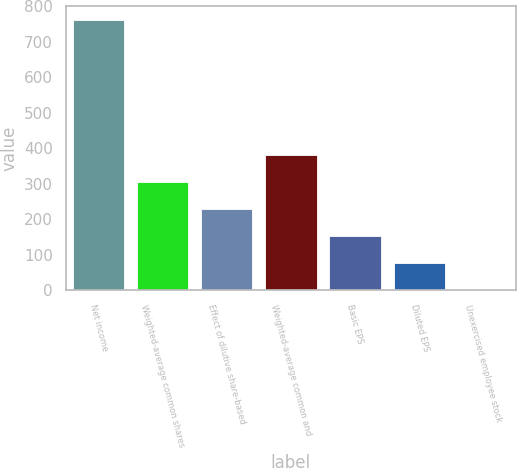Convert chart. <chart><loc_0><loc_0><loc_500><loc_500><bar_chart><fcel>Net income<fcel>Weighted-average common shares<fcel>Effect of dilutive share-based<fcel>Weighted-average common and<fcel>Basic EPS<fcel>Diluted EPS<fcel>Unexercised employee stock<nl><fcel>762<fcel>305.1<fcel>228.95<fcel>381.25<fcel>152.8<fcel>76.65<fcel>0.5<nl></chart> 